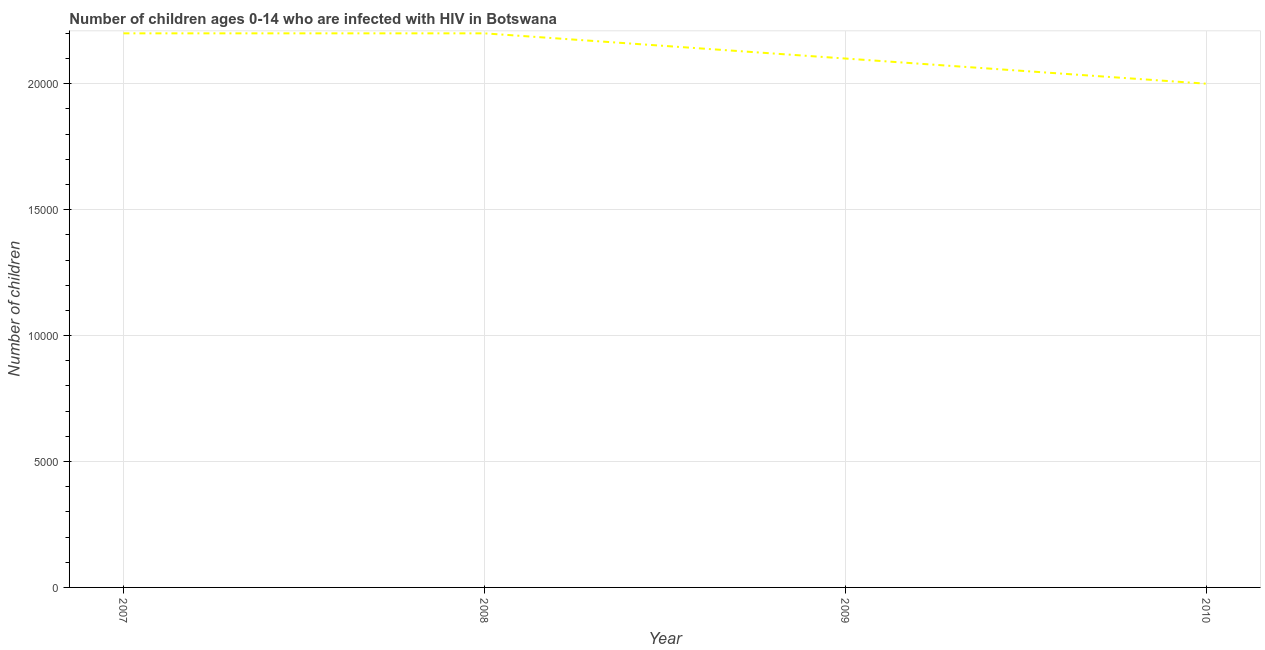What is the number of children living with hiv in 2010?
Provide a short and direct response. 2.00e+04. Across all years, what is the maximum number of children living with hiv?
Provide a succinct answer. 2.20e+04. Across all years, what is the minimum number of children living with hiv?
Your answer should be very brief. 2.00e+04. In which year was the number of children living with hiv maximum?
Give a very brief answer. 2007. In which year was the number of children living with hiv minimum?
Offer a very short reply. 2010. What is the sum of the number of children living with hiv?
Provide a succinct answer. 8.50e+04. What is the average number of children living with hiv per year?
Offer a terse response. 2.12e+04. What is the median number of children living with hiv?
Give a very brief answer. 2.15e+04. In how many years, is the number of children living with hiv greater than 11000 ?
Your response must be concise. 4. What is the ratio of the number of children living with hiv in 2009 to that in 2010?
Your response must be concise. 1.05. Is the difference between the number of children living with hiv in 2007 and 2009 greater than the difference between any two years?
Ensure brevity in your answer.  No. Does the number of children living with hiv monotonically increase over the years?
Offer a very short reply. No. How many lines are there?
Make the answer very short. 1. How many years are there in the graph?
Provide a succinct answer. 4. Are the values on the major ticks of Y-axis written in scientific E-notation?
Ensure brevity in your answer.  No. Does the graph contain any zero values?
Provide a short and direct response. No. What is the title of the graph?
Ensure brevity in your answer.  Number of children ages 0-14 who are infected with HIV in Botswana. What is the label or title of the Y-axis?
Your response must be concise. Number of children. What is the Number of children in 2007?
Your answer should be very brief. 2.20e+04. What is the Number of children of 2008?
Offer a very short reply. 2.20e+04. What is the Number of children in 2009?
Keep it short and to the point. 2.10e+04. What is the Number of children of 2010?
Offer a terse response. 2.00e+04. What is the difference between the Number of children in 2008 and 2009?
Offer a terse response. 1000. What is the ratio of the Number of children in 2007 to that in 2009?
Provide a succinct answer. 1.05. What is the ratio of the Number of children in 2007 to that in 2010?
Provide a short and direct response. 1.1. What is the ratio of the Number of children in 2008 to that in 2009?
Provide a succinct answer. 1.05. 